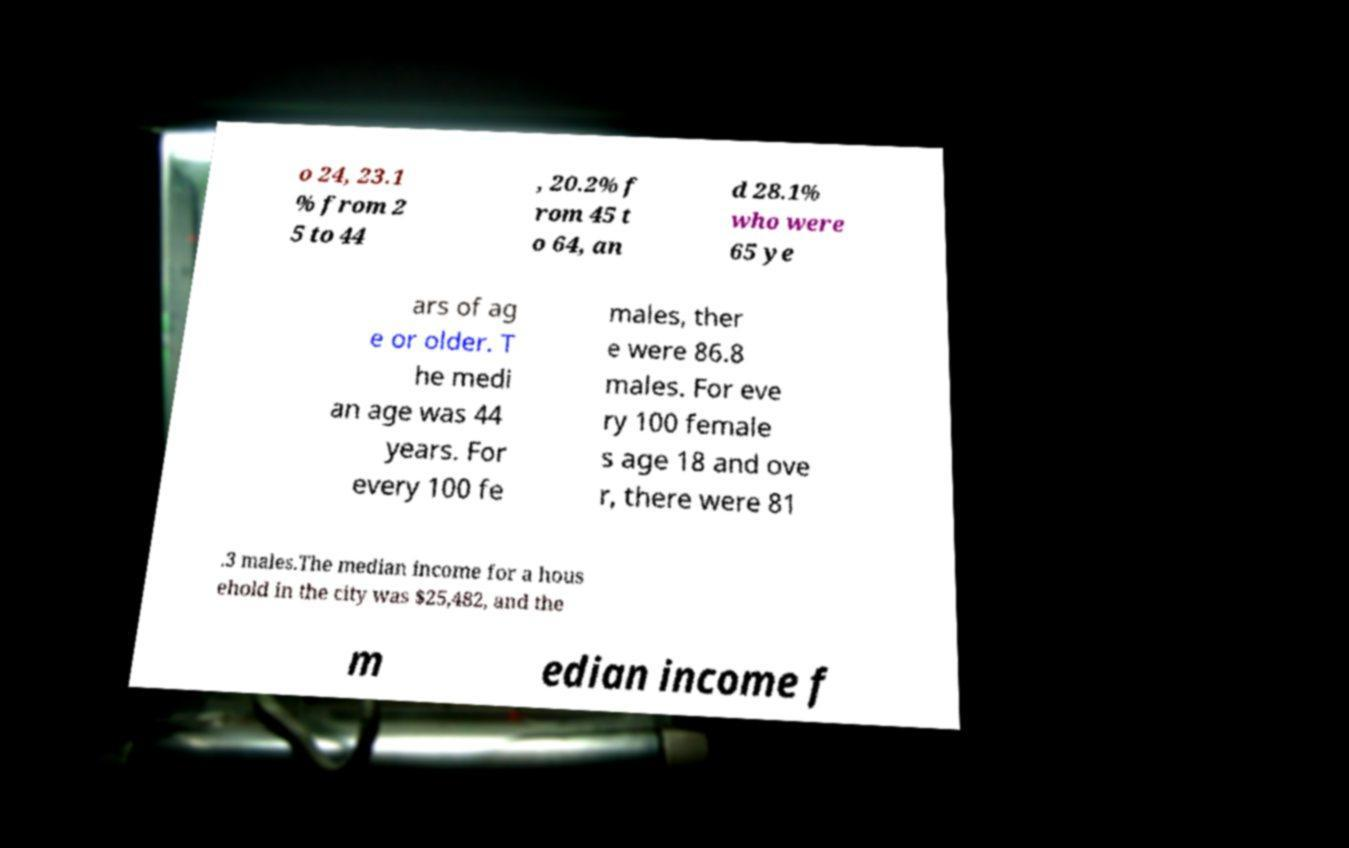Can you read and provide the text displayed in the image?This photo seems to have some interesting text. Can you extract and type it out for me? o 24, 23.1 % from 2 5 to 44 , 20.2% f rom 45 t o 64, an d 28.1% who were 65 ye ars of ag e or older. T he medi an age was 44 years. For every 100 fe males, ther e were 86.8 males. For eve ry 100 female s age 18 and ove r, there were 81 .3 males.The median income for a hous ehold in the city was $25,482, and the m edian income f 